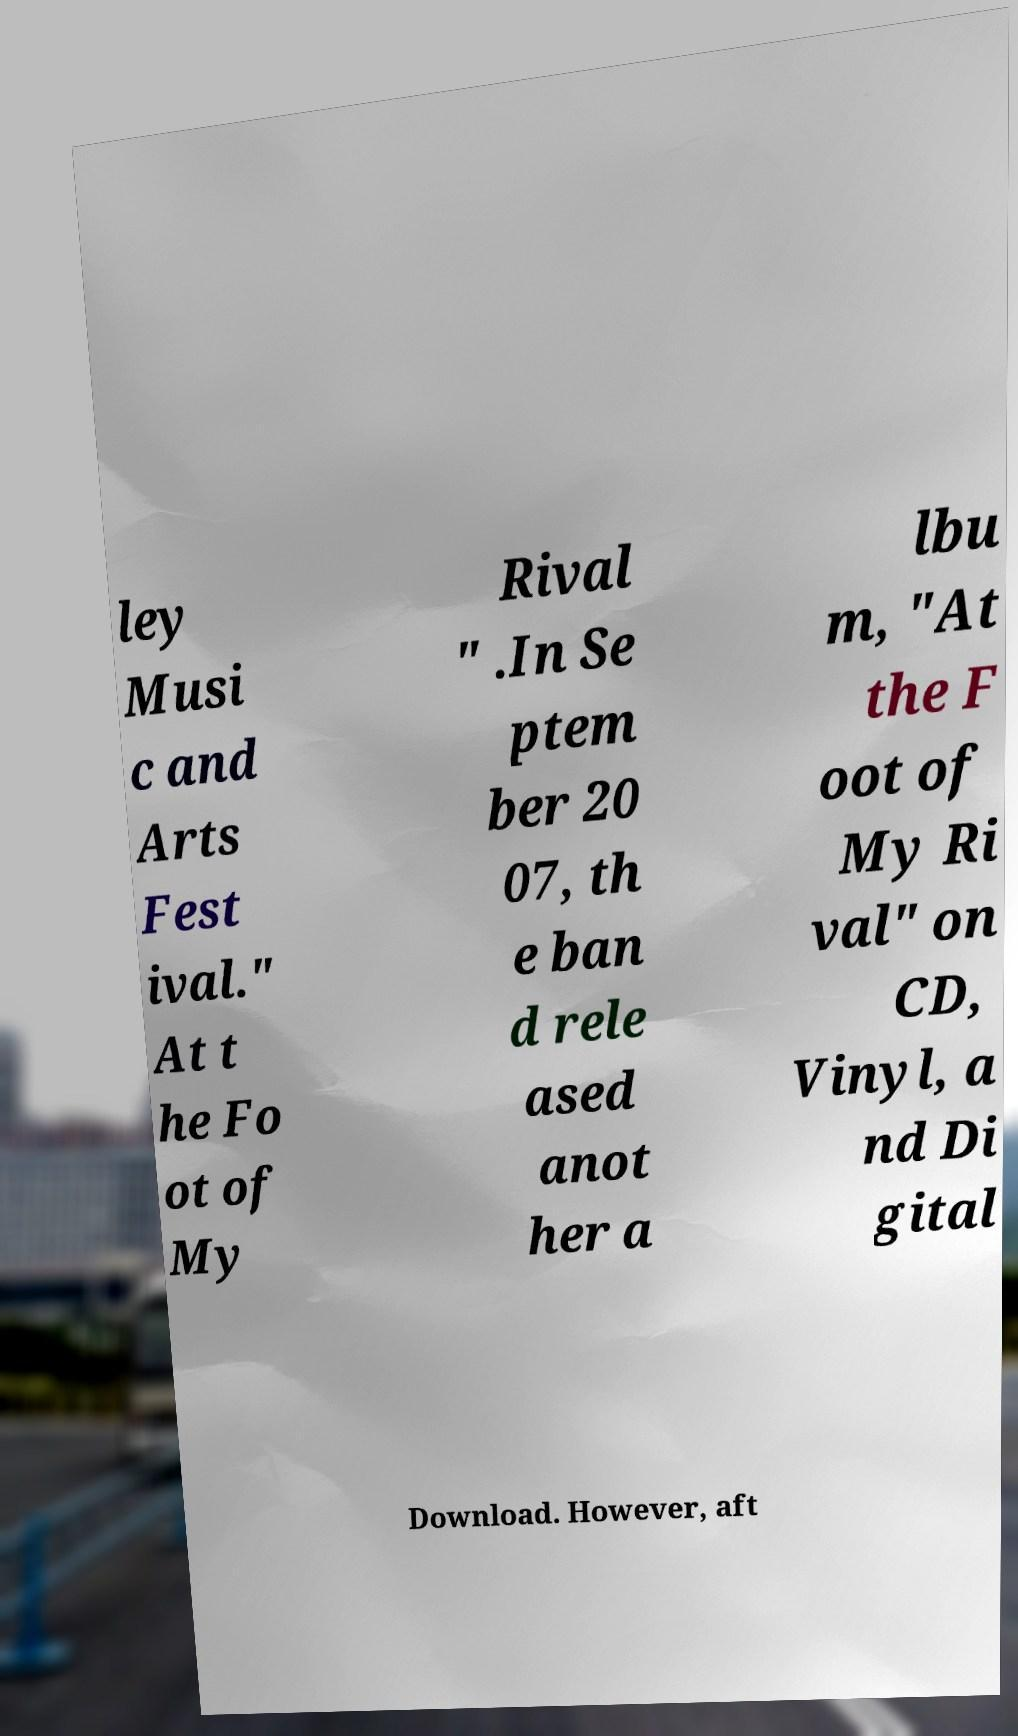Please read and relay the text visible in this image. What does it say? ley Musi c and Arts Fest ival." At t he Fo ot of My Rival " .In Se ptem ber 20 07, th e ban d rele ased anot her a lbu m, "At the F oot of My Ri val" on CD, Vinyl, a nd Di gital Download. However, aft 